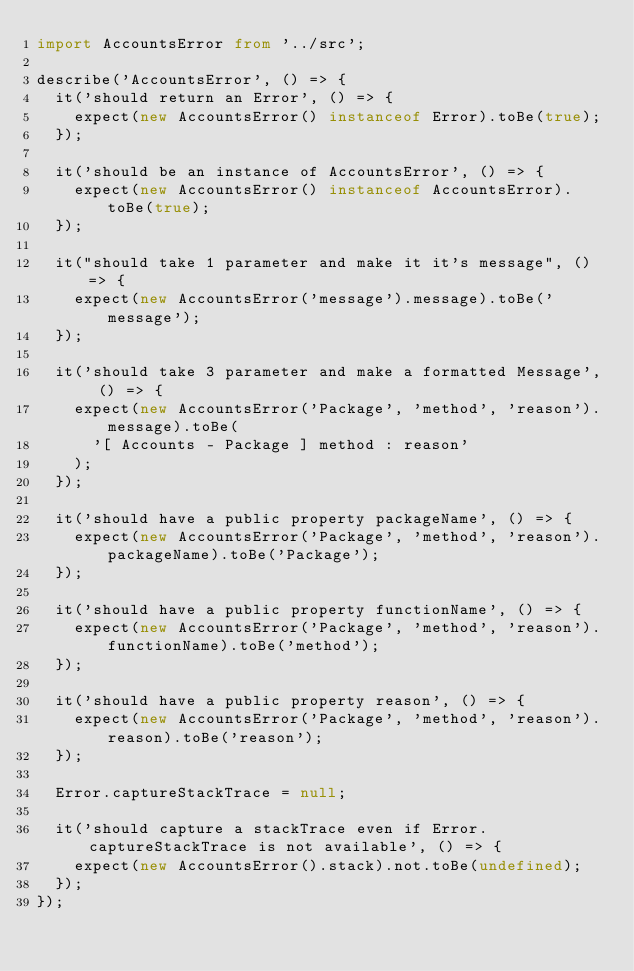<code> <loc_0><loc_0><loc_500><loc_500><_TypeScript_>import AccountsError from '../src';

describe('AccountsError', () => {
  it('should return an Error', () => {
    expect(new AccountsError() instanceof Error).toBe(true);
  });

  it('should be an instance of AccountsError', () => {
    expect(new AccountsError() instanceof AccountsError).toBe(true);
  });

  it("should take 1 parameter and make it it's message", () => {
    expect(new AccountsError('message').message).toBe('message');
  });

  it('should take 3 parameter and make a formatted Message', () => {
    expect(new AccountsError('Package', 'method', 'reason').message).toBe(
      '[ Accounts - Package ] method : reason'
    );
  });

  it('should have a public property packageName', () => {
    expect(new AccountsError('Package', 'method', 'reason').packageName).toBe('Package');
  });

  it('should have a public property functionName', () => {
    expect(new AccountsError('Package', 'method', 'reason').functionName).toBe('method');
  });

  it('should have a public property reason', () => {
    expect(new AccountsError('Package', 'method', 'reason').reason).toBe('reason');
  });

  Error.captureStackTrace = null;

  it('should capture a stackTrace even if Error.captureStackTrace is not available', () => {
    expect(new AccountsError().stack).not.toBe(undefined);
  });
});
</code> 